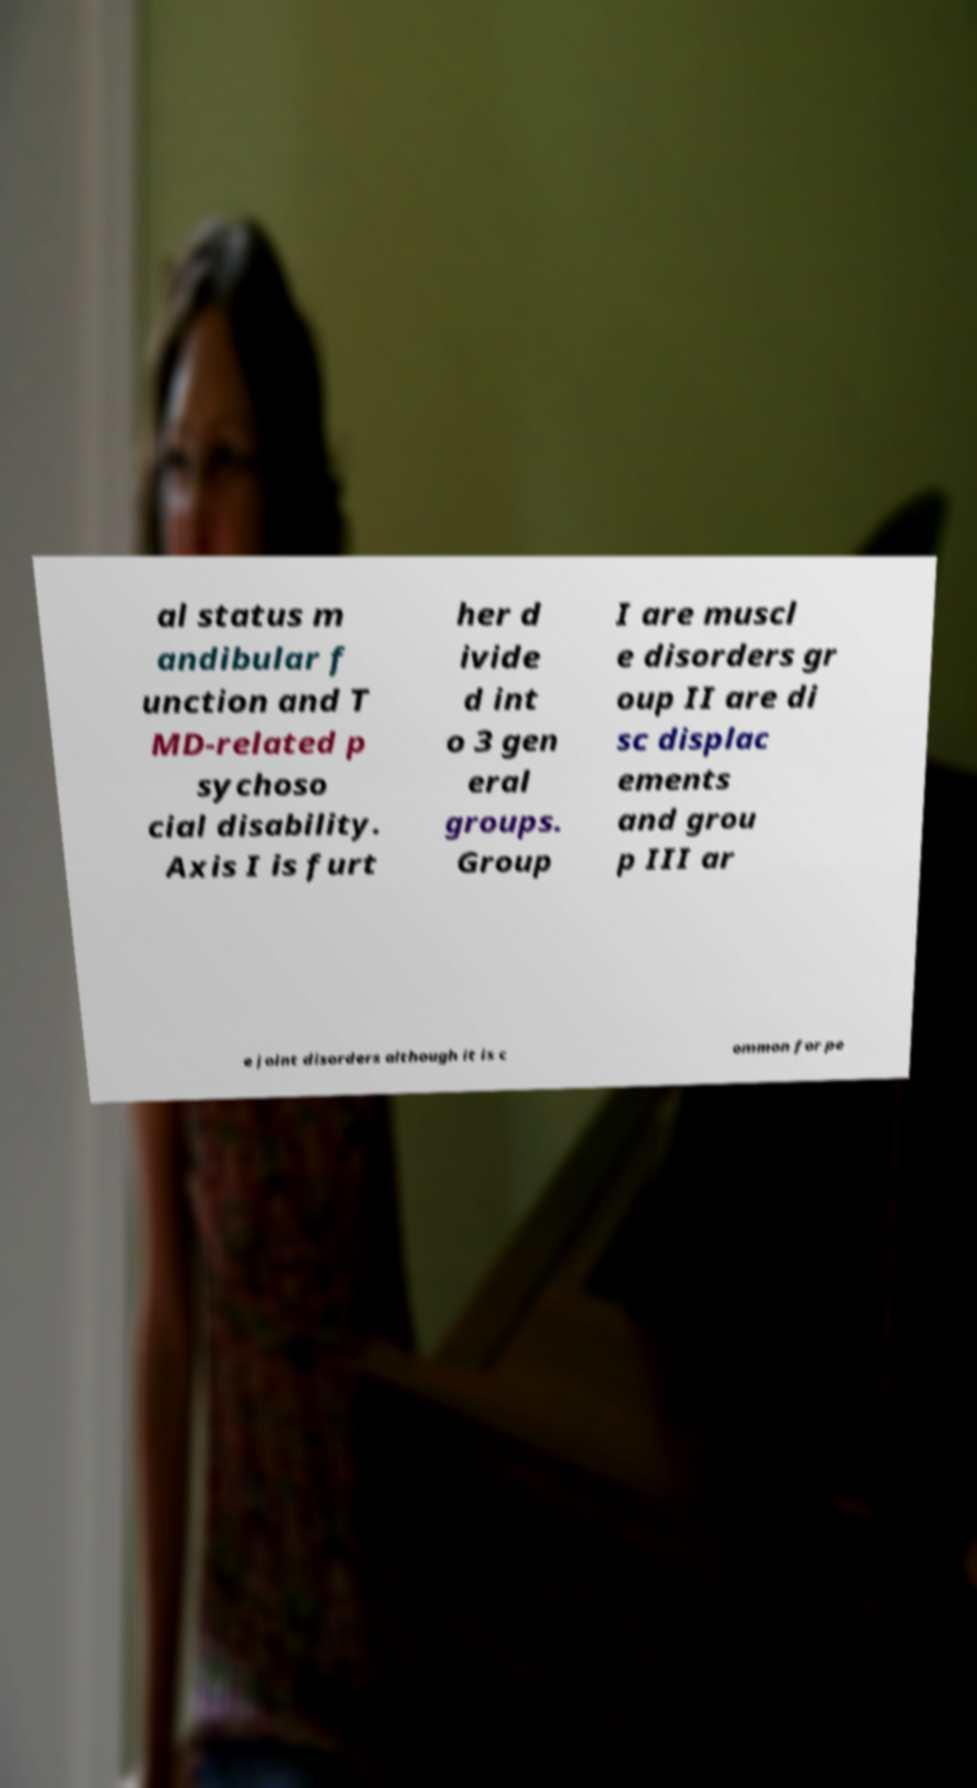There's text embedded in this image that I need extracted. Can you transcribe it verbatim? al status m andibular f unction and T MD-related p sychoso cial disability. Axis I is furt her d ivide d int o 3 gen eral groups. Group I are muscl e disorders gr oup II are di sc displac ements and grou p III ar e joint disorders although it is c ommon for pe 